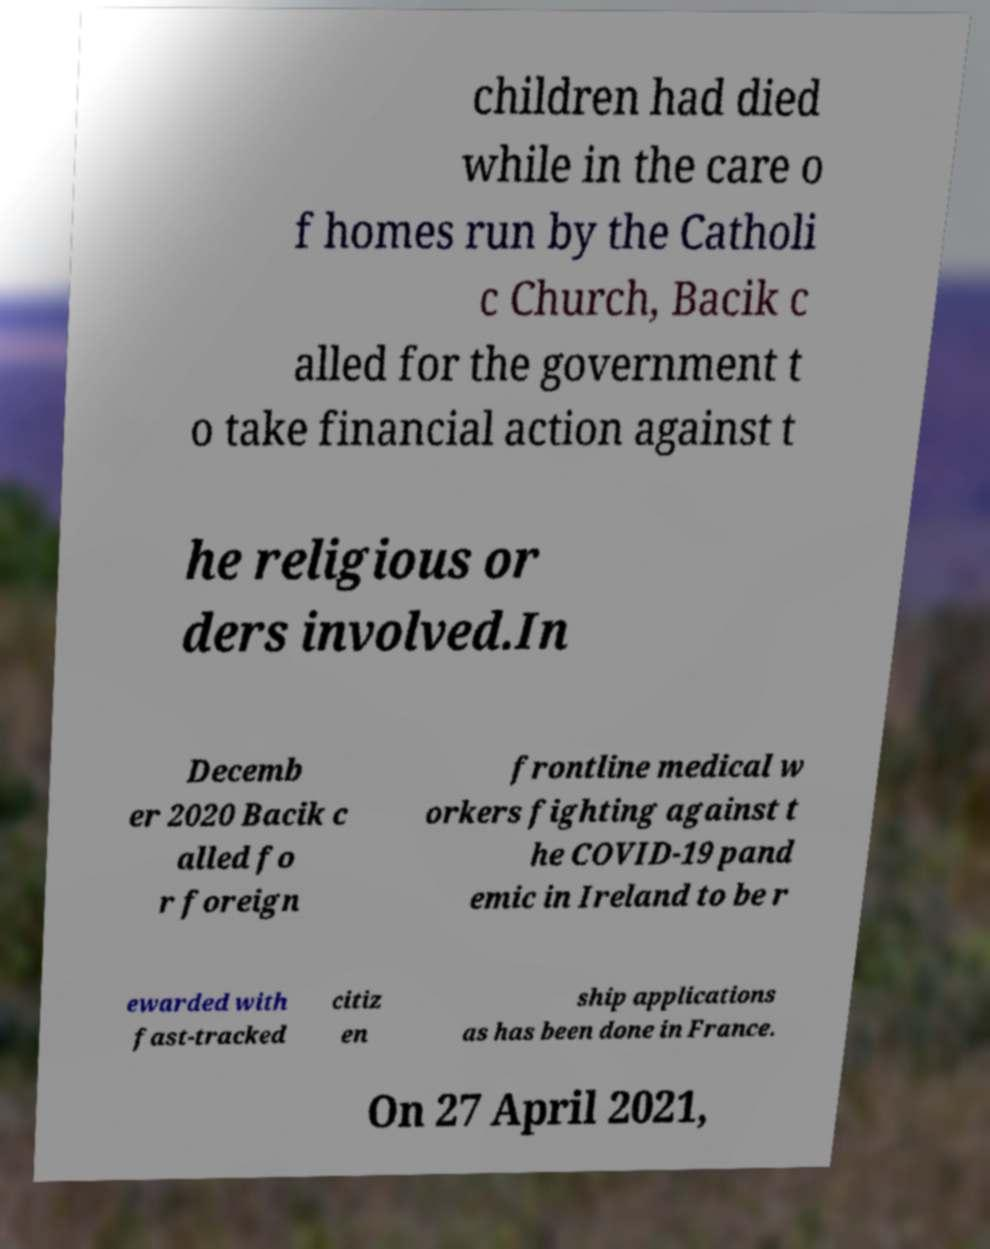Please read and relay the text visible in this image. What does it say? children had died while in the care o f homes run by the Catholi c Church, Bacik c alled for the government t o take financial action against t he religious or ders involved.In Decemb er 2020 Bacik c alled fo r foreign frontline medical w orkers fighting against t he COVID-19 pand emic in Ireland to be r ewarded with fast-tracked citiz en ship applications as has been done in France. On 27 April 2021, 